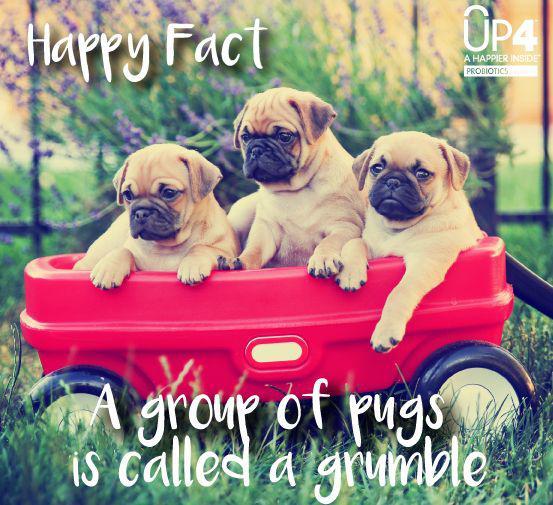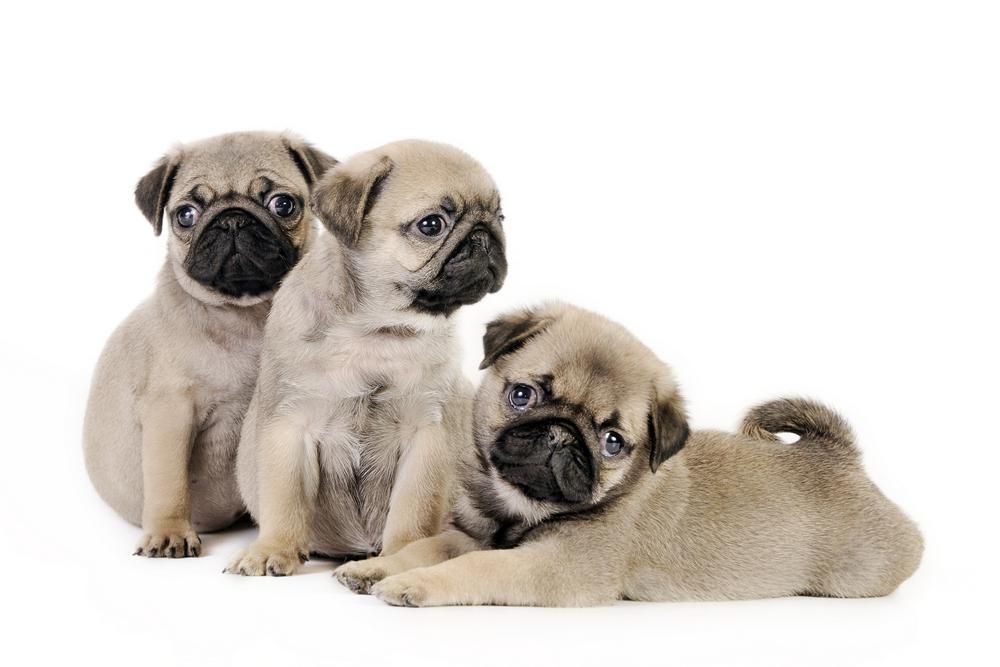The first image is the image on the left, the second image is the image on the right. Evaluate the accuracy of this statement regarding the images: "there are at least five dogs in the image on the left". Is it true? Answer yes or no. No. The first image is the image on the left, the second image is the image on the right. Analyze the images presented: Is the assertion "There are more pug dogs in the left image than in the right." valid? Answer yes or no. No. 